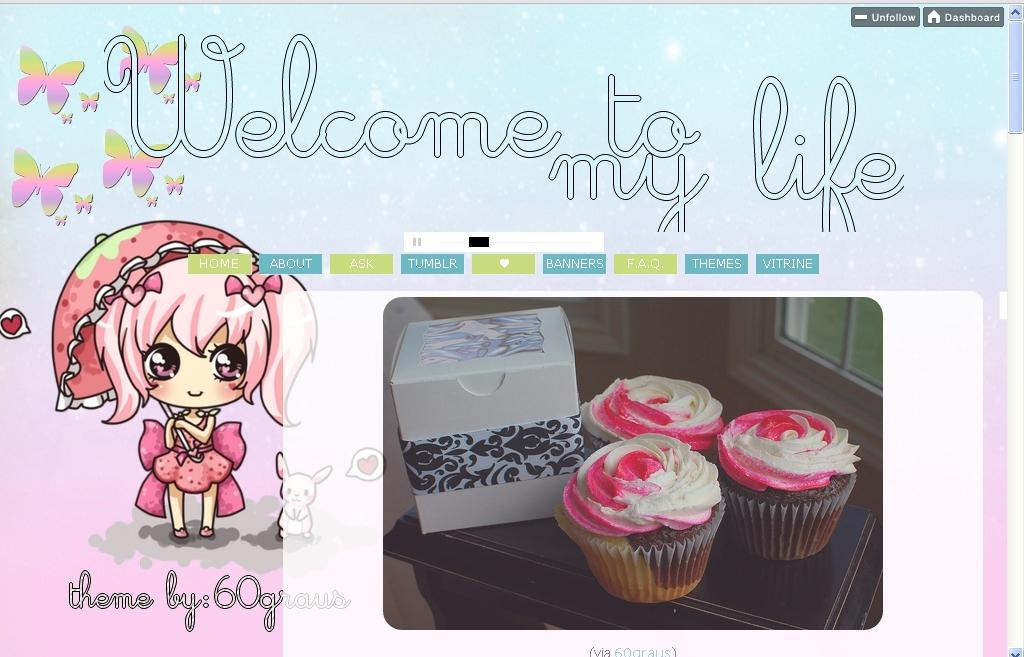How was the image altered or modified? The image is edited. What is the main subject in the image? There is a depiction of a doll in the image. What type of food can be seen in the image? There are cupcakes in the image. What is located on the table in the image? There is an object on the table in the image. What type of window is visible in the image? There is a glass window in the image. Is there any text present in the image? Yes, there is some text on the image. How many plastic plants are visible in the image? There are no plastic plants present in the image. Is there a goldfish swimming in the glass window in the image? There is no goldfish visible in the image, and the glass window is not a fish tank. 